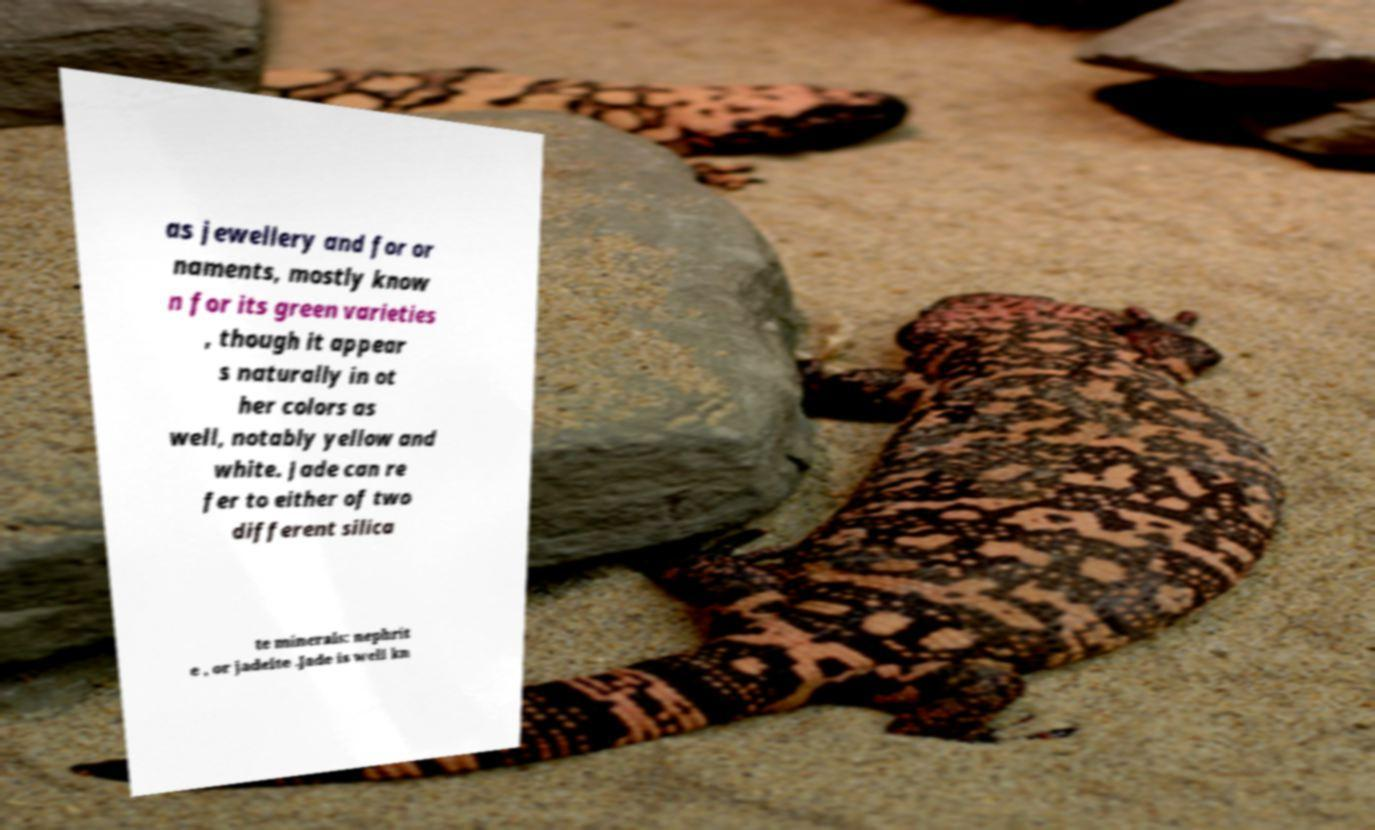Please identify and transcribe the text found in this image. as jewellery and for or naments, mostly know n for its green varieties , though it appear s naturally in ot her colors as well, notably yellow and white. Jade can re fer to either of two different silica te minerals: nephrit e , or jadeite .Jade is well kn 